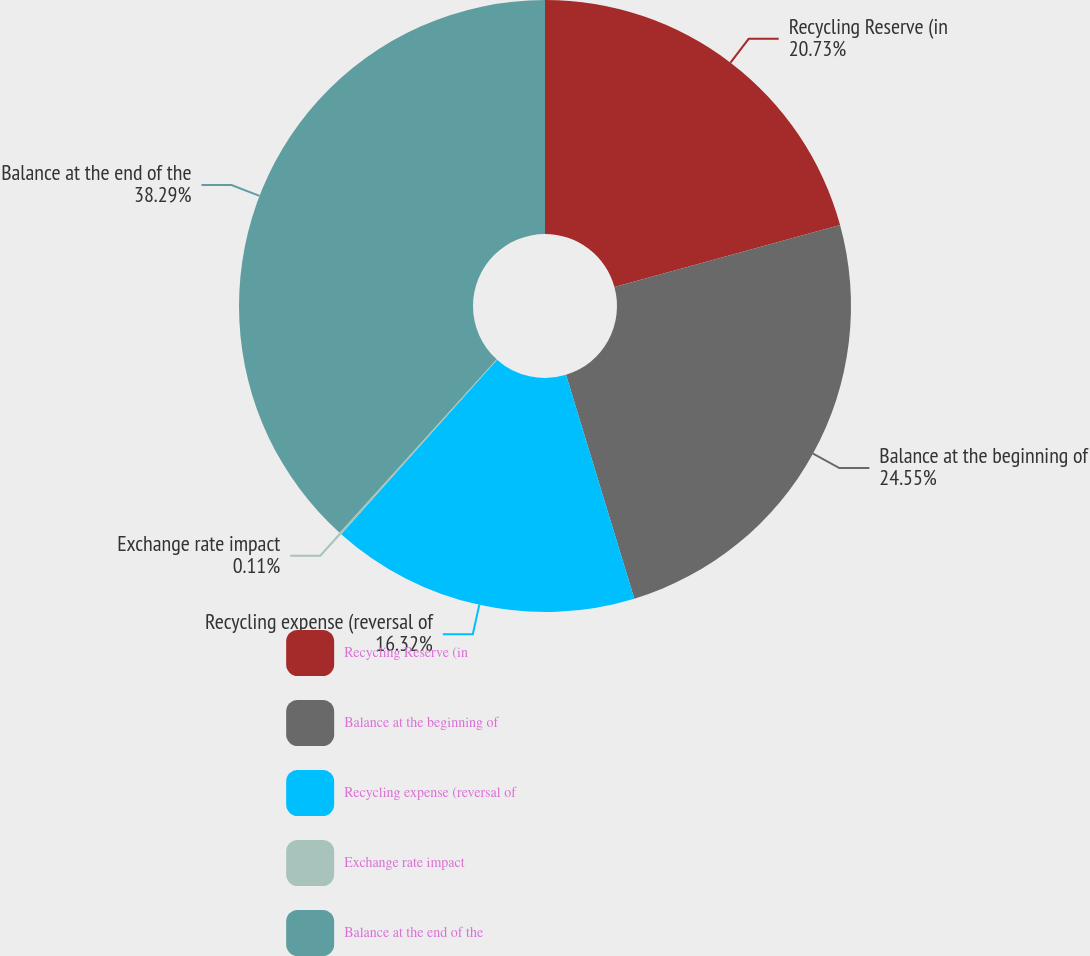Convert chart to OTSL. <chart><loc_0><loc_0><loc_500><loc_500><pie_chart><fcel>Recycling Reserve (in<fcel>Balance at the beginning of<fcel>Recycling expense (reversal of<fcel>Exchange rate impact<fcel>Balance at the end of the<nl><fcel>20.73%<fcel>24.55%<fcel>16.32%<fcel>0.11%<fcel>38.28%<nl></chart> 